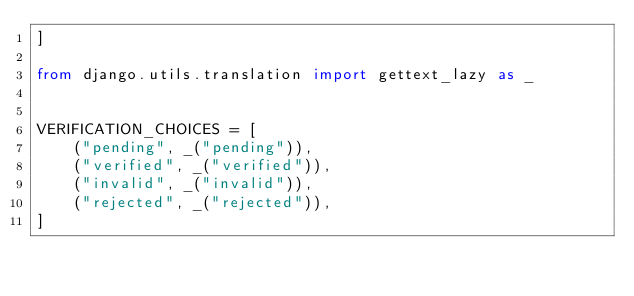Convert code to text. <code><loc_0><loc_0><loc_500><loc_500><_Python_>]

from django.utils.translation import gettext_lazy as _


VERIFICATION_CHOICES = [
    ("pending", _("pending")),
    ("verified", _("verified")),
    ("invalid", _("invalid")),
    ("rejected", _("rejected")),
]
</code> 